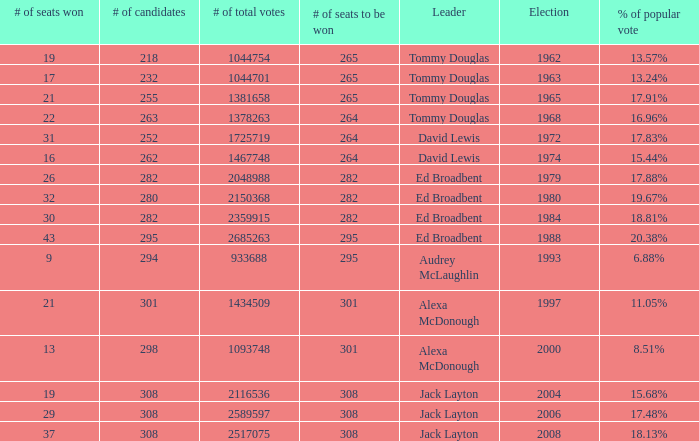Name the number of candidates for # of seats won being 43 295.0. Give me the full table as a dictionary. {'header': ['# of seats won', '# of candidates', '# of total votes', '# of seats to be won', 'Leader', 'Election', '% of popular vote'], 'rows': [['19', '218', '1044754', '265', 'Tommy Douglas', '1962', '13.57%'], ['17', '232', '1044701', '265', 'Tommy Douglas', '1963', '13.24%'], ['21', '255', '1381658', '265', 'Tommy Douglas', '1965', '17.91%'], ['22', '263', '1378263', '264', 'Tommy Douglas', '1968', '16.96%'], ['31', '252', '1725719', '264', 'David Lewis', '1972', '17.83%'], ['16', '262', '1467748', '264', 'David Lewis', '1974', '15.44%'], ['26', '282', '2048988', '282', 'Ed Broadbent', '1979', '17.88%'], ['32', '280', '2150368', '282', 'Ed Broadbent', '1980', '19.67%'], ['30', '282', '2359915', '282', 'Ed Broadbent', '1984', '18.81%'], ['43', '295', '2685263', '295', 'Ed Broadbent', '1988', '20.38%'], ['9', '294', '933688', '295', 'Audrey McLaughlin', '1993', '6.88%'], ['21', '301', '1434509', '301', 'Alexa McDonough', '1997', '11.05%'], ['13', '298', '1093748', '301', 'Alexa McDonough', '2000', '8.51%'], ['19', '308', '2116536', '308', 'Jack Layton', '2004', '15.68%'], ['29', '308', '2589597', '308', 'Jack Layton', '2006', '17.48%'], ['37', '308', '2517075', '308', 'Jack Layton', '2008', '18.13%']]} 